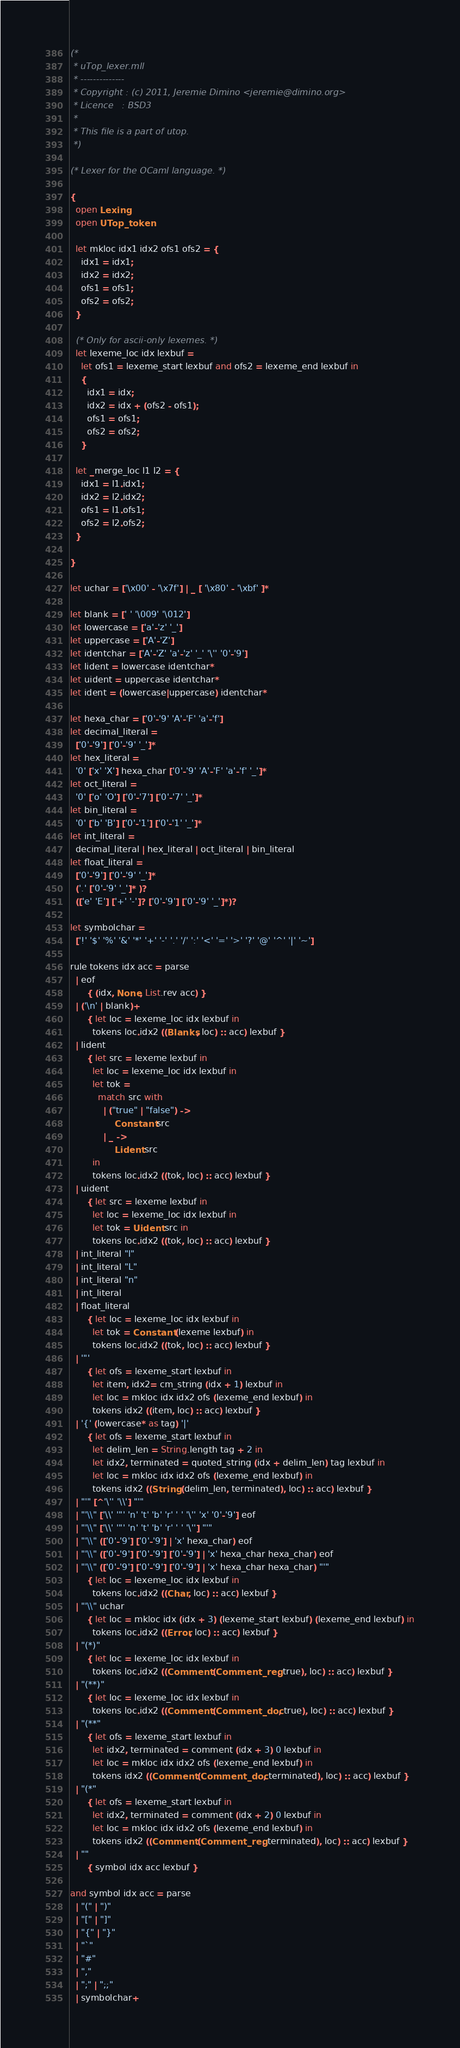<code> <loc_0><loc_0><loc_500><loc_500><_OCaml_>(*
 * uTop_lexer.mll
 * --------------
 * Copyright : (c) 2011, Jeremie Dimino <jeremie@dimino.org>
 * Licence   : BSD3
 *
 * This file is a part of utop.
 *)

(* Lexer for the OCaml language. *)

{
  open Lexing
  open UTop_token

  let mkloc idx1 idx2 ofs1 ofs2 = {
    idx1 = idx1;
    idx2 = idx2;
    ofs1 = ofs1;
    ofs2 = ofs2;
  }

  (* Only for ascii-only lexemes. *)
  let lexeme_loc idx lexbuf =
    let ofs1 = lexeme_start lexbuf and ofs2 = lexeme_end lexbuf in
    {
      idx1 = idx;
      idx2 = idx + (ofs2 - ofs1);
      ofs1 = ofs1;
      ofs2 = ofs2;
    }

  let _merge_loc l1 l2 = {
    idx1 = l1.idx1;
    idx2 = l2.idx2;
    ofs1 = l1.ofs1;
    ofs2 = l2.ofs2;
  }

}

let uchar = ['\x00' - '\x7f'] | _ [ '\x80' - '\xbf' ]*

let blank = [' ' '\009' '\012']
let lowercase = ['a'-'z' '_']
let uppercase = ['A'-'Z']
let identchar = ['A'-'Z' 'a'-'z' '_' '\'' '0'-'9']
let lident = lowercase identchar*
let uident = uppercase identchar*
let ident = (lowercase|uppercase) identchar*

let hexa_char = ['0'-'9' 'A'-'F' 'a'-'f']
let decimal_literal =
  ['0'-'9'] ['0'-'9' '_']*
let hex_literal =
  '0' ['x' 'X'] hexa_char ['0'-'9' 'A'-'F' 'a'-'f' '_']*
let oct_literal =
  '0' ['o' 'O'] ['0'-'7'] ['0'-'7' '_']*
let bin_literal =
  '0' ['b' 'B'] ['0'-'1'] ['0'-'1' '_']*
let int_literal =
  decimal_literal | hex_literal | oct_literal | bin_literal
let float_literal =
  ['0'-'9'] ['0'-'9' '_']*
  ('.' ['0'-'9' '_']* )?
  (['e' 'E'] ['+' '-']? ['0'-'9'] ['0'-'9' '_']*)?

let symbolchar =
  ['!' '$' '%' '&' '*' '+' '-' '.' '/' ':' '<' '=' '>' '?' '@' '^' '|' '~']

rule tokens idx acc = parse
  | eof
      { (idx, None, List.rev acc) }
  | ('\n' | blank)+
      { let loc = lexeme_loc idx lexbuf in
        tokens loc.idx2 ((Blanks, loc) :: acc) lexbuf }
  | lident
      { let src = lexeme lexbuf in
        let loc = lexeme_loc idx lexbuf in
        let tok =
          match src with
            | ("true" | "false") ->
                Constant src
            | _ ->
                Lident src
        in
        tokens loc.idx2 ((tok, loc) :: acc) lexbuf }
  | uident
      { let src = lexeme lexbuf in
        let loc = lexeme_loc idx lexbuf in
        let tok = Uident src in
        tokens loc.idx2 ((tok, loc) :: acc) lexbuf }
  | int_literal "l"
  | int_literal "L"
  | int_literal "n"
  | int_literal
  | float_literal
      { let loc = lexeme_loc idx lexbuf in
        let tok = Constant (lexeme lexbuf) in
        tokens loc.idx2 ((tok, loc) :: acc) lexbuf }
  | '"'
      { let ofs = lexeme_start lexbuf in
        let item, idx2= cm_string (idx + 1) lexbuf in
        let loc = mkloc idx idx2 ofs (lexeme_end lexbuf) in
        tokens idx2 ((item, loc) :: acc) lexbuf }
  | '{' (lowercase* as tag) '|'
      { let ofs = lexeme_start lexbuf in
        let delim_len = String.length tag + 2 in
        let idx2, terminated = quoted_string (idx + delim_len) tag lexbuf in
        let loc = mkloc idx idx2 ofs (lexeme_end lexbuf) in
        tokens idx2 ((String (delim_len, terminated), loc) :: acc) lexbuf }
  | "'" [^'\'' '\\'] "'"
  | "'\\" ['\\' '"' 'n' 't' 'b' 'r' ' ' '\'' 'x' '0'-'9'] eof
  | "'\\" ['\\' '"' 'n' 't' 'b' 'r' ' ' '\''] "'"
  | "'\\" (['0'-'9'] ['0'-'9'] | 'x' hexa_char) eof
  | "'\\" (['0'-'9'] ['0'-'9'] ['0'-'9'] | 'x' hexa_char hexa_char) eof
  | "'\\" (['0'-'9'] ['0'-'9'] ['0'-'9'] | 'x' hexa_char hexa_char) "'"
      { let loc = lexeme_loc idx lexbuf in
        tokens loc.idx2 ((Char, loc) :: acc) lexbuf }
  | "'\\" uchar
      { let loc = mkloc idx (idx + 3) (lexeme_start lexbuf) (lexeme_end lexbuf) in
        tokens loc.idx2 ((Error, loc) :: acc) lexbuf }
  | "(*)"
      { let loc = lexeme_loc idx lexbuf in
        tokens loc.idx2 ((Comment (Comment_reg, true), loc) :: acc) lexbuf }
  | "(**)"
      { let loc = lexeme_loc idx lexbuf in
        tokens loc.idx2 ((Comment (Comment_doc, true), loc) :: acc) lexbuf }
  | "(**"
      { let ofs = lexeme_start lexbuf in
        let idx2, terminated = comment (idx + 3) 0 lexbuf in
        let loc = mkloc idx idx2 ofs (lexeme_end lexbuf) in
        tokens idx2 ((Comment (Comment_doc, terminated), loc) :: acc) lexbuf }
  | "(*"
      { let ofs = lexeme_start lexbuf in
        let idx2, terminated = comment (idx + 2) 0 lexbuf in
        let loc = mkloc idx idx2 ofs (lexeme_end lexbuf) in
        tokens idx2 ((Comment (Comment_reg, terminated), loc) :: acc) lexbuf }
  | ""
      { symbol idx acc lexbuf }

and symbol idx acc = parse
  | "(" | ")"
  | "[" | "]"
  | "{" | "}"
  | "`"
  | "#"
  | ","
  | ";" | ";;"
  | symbolchar+</code> 